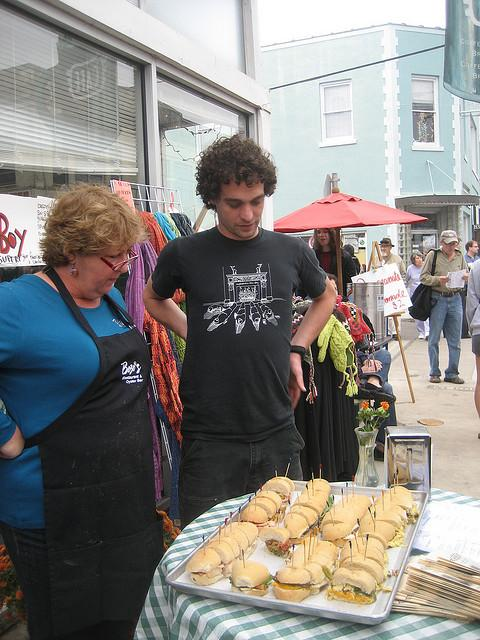What is the tray made from? Please explain your reasoning. steel. It's a serving tray that is made out of metal. 